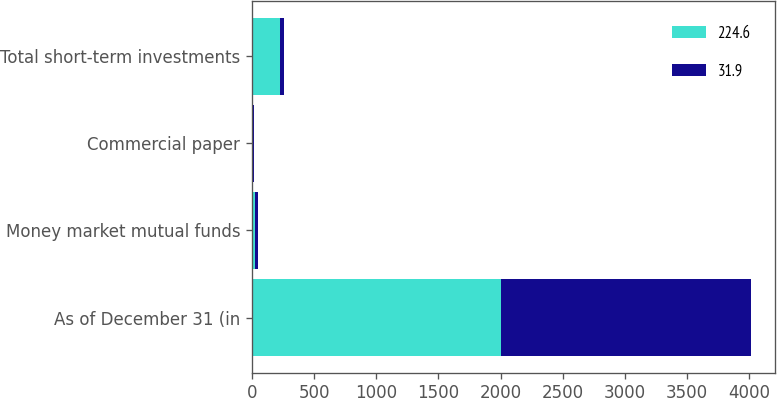Convert chart. <chart><loc_0><loc_0><loc_500><loc_500><stacked_bar_chart><ecel><fcel>As of December 31 (in<fcel>Money market mutual funds<fcel>Commercial paper<fcel>Total short-term investments<nl><fcel>224.6<fcel>2006<fcel>23<fcel>8.3<fcel>224.6<nl><fcel>31.9<fcel>2005<fcel>24.3<fcel>7.6<fcel>31.9<nl></chart> 